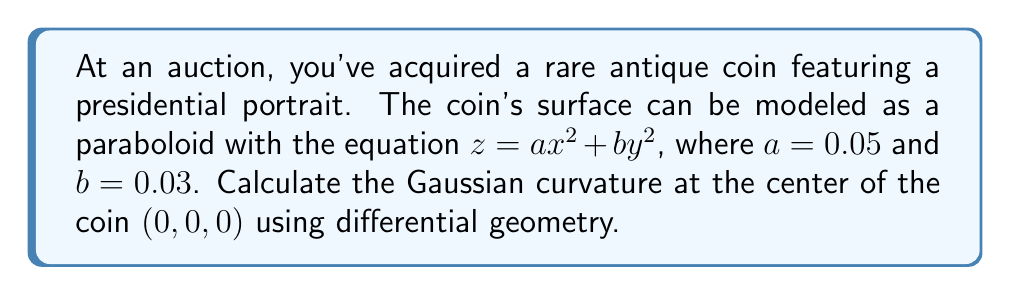Teach me how to tackle this problem. To calculate the Gaussian curvature of the paraboloid surface at the center point, we'll follow these steps:

1. The surface is given by $z = f(x,y) = ax^2 + by^2$, where $a = 0.05$ and $b = 0.03$.

2. We need to calculate the partial derivatives:
   $f_x = 2ax = 0.1x$
   $f_y = 2by = 0.06y$
   $f_{xx} = 2a = 0.1$
   $f_{yy} = 2b = 0.06$
   $f_{xy} = f_{yx} = 0$

3. The Gaussian curvature K is given by:
   
   $$K = \frac{f_{xx}f_{yy} - f_{xy}^2}{(1 + f_x^2 + f_y^2)^2}$$

4. At the center point (0, 0, 0):
   $f_x = f_y = 0$
   $f_{xx} = 0.1$
   $f_{yy} = 0.06$
   $f_{xy} = 0$

5. Substituting these values into the Gaussian curvature formula:

   $$K = \frac{(0.1)(0.06) - 0^2}{(1 + 0^2 + 0^2)^2} = \frac{0.006}{1} = 0.006$$

Therefore, the Gaussian curvature at the center of the coin is 0.006.
Answer: $K = 0.006$ 